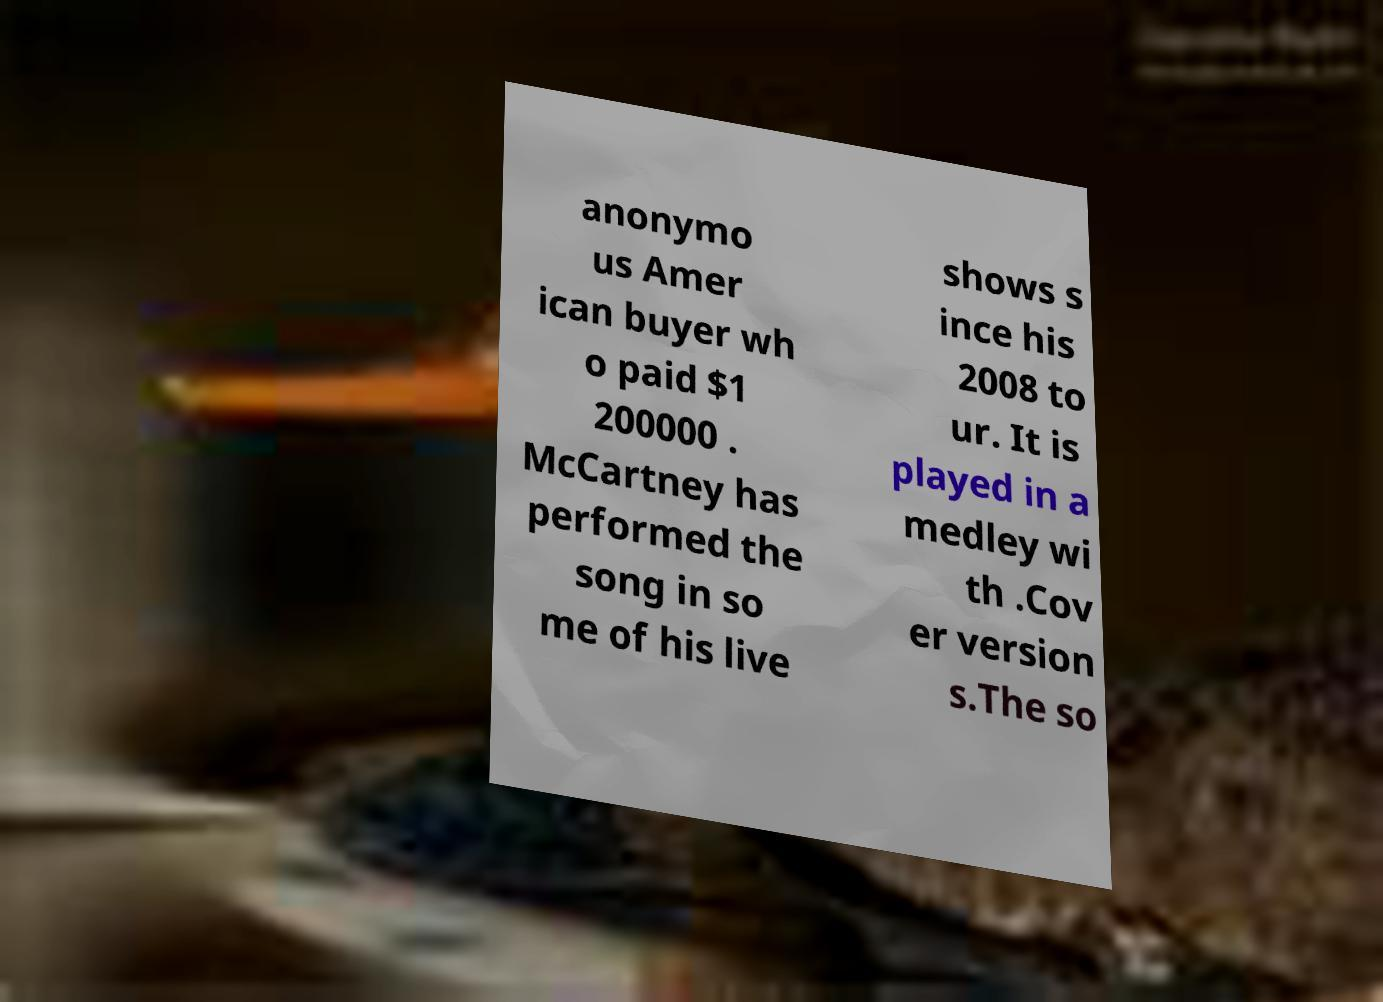Please read and relay the text visible in this image. What does it say? anonymo us Amer ican buyer wh o paid $1 200000 . McCartney has performed the song in so me of his live shows s ince his 2008 to ur. It is played in a medley wi th .Cov er version s.The so 